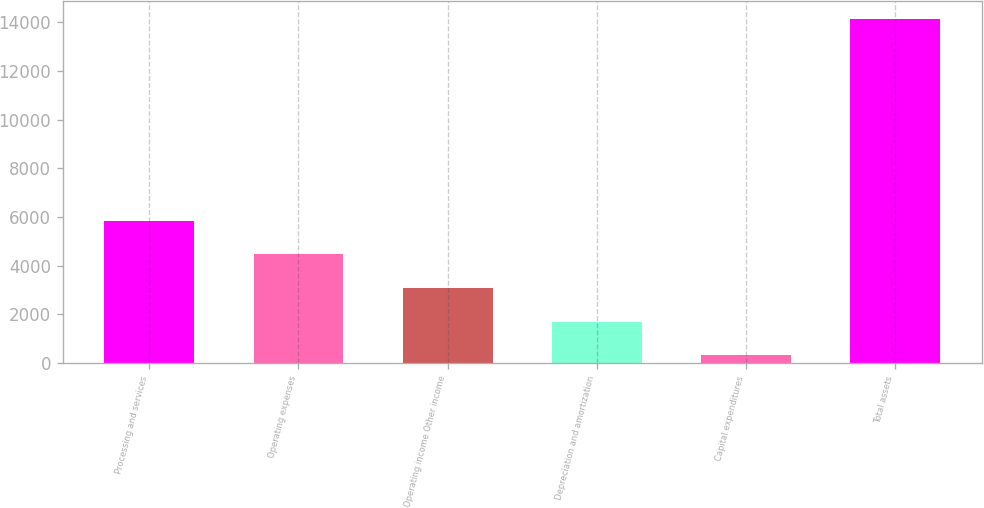Convert chart to OTSL. <chart><loc_0><loc_0><loc_500><loc_500><bar_chart><fcel>Processing and services<fcel>Operating expenses<fcel>Operating income Other income<fcel>Depreciation and amortization<fcel>Capital expenditures<fcel>Total assets<nl><fcel>5849.52<fcel>4465.24<fcel>3080.96<fcel>1696.68<fcel>312.4<fcel>14155.2<nl></chart> 